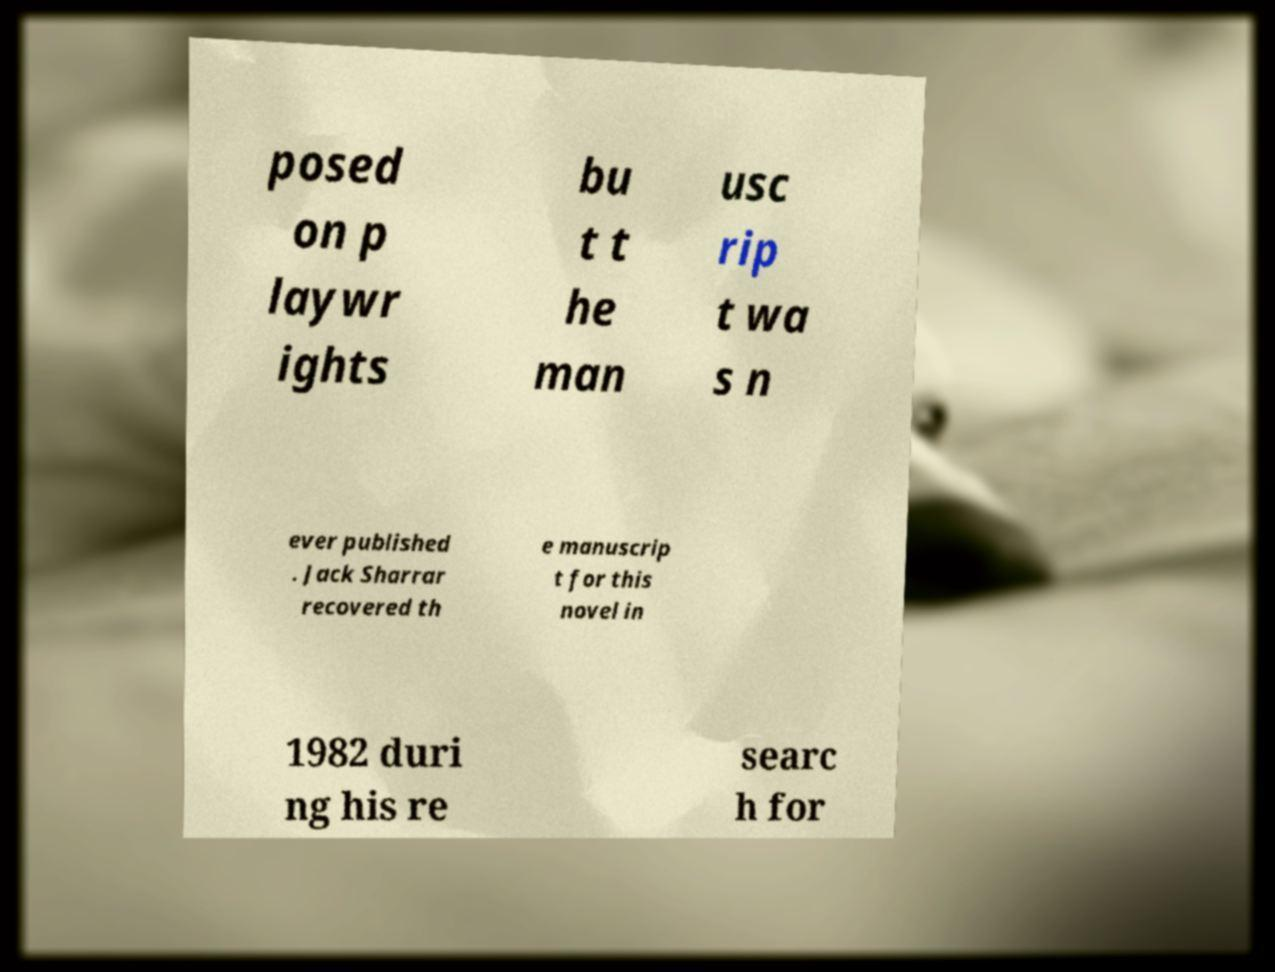What messages or text are displayed in this image? I need them in a readable, typed format. posed on p laywr ights bu t t he man usc rip t wa s n ever published . Jack Sharrar recovered th e manuscrip t for this novel in 1982 duri ng his re searc h for 